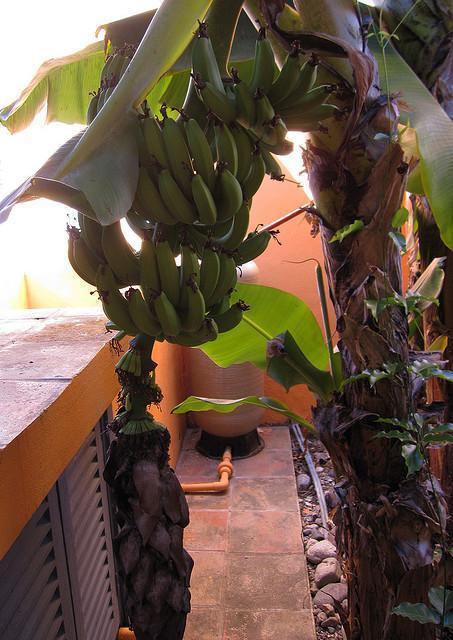How many bananas are in the picture?
Give a very brief answer. 3. 